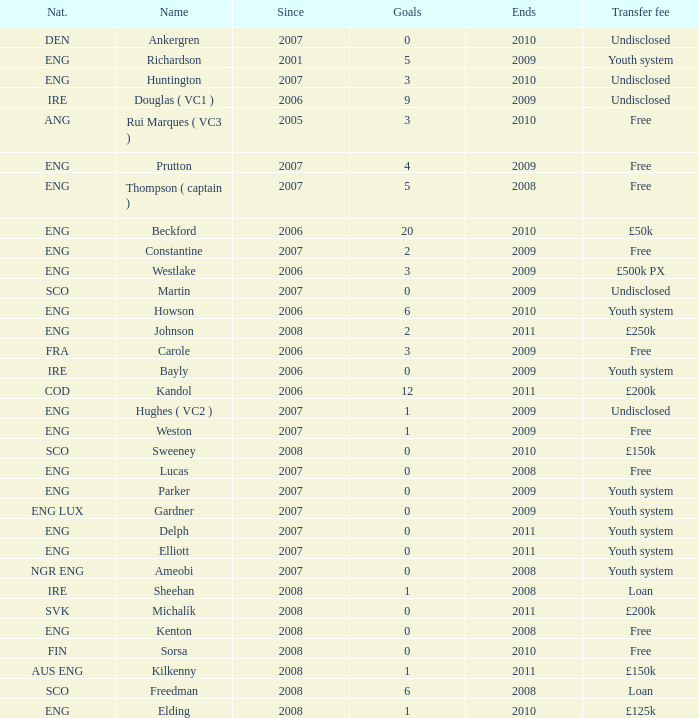Specify the typical limits for weston. 2009.0. 